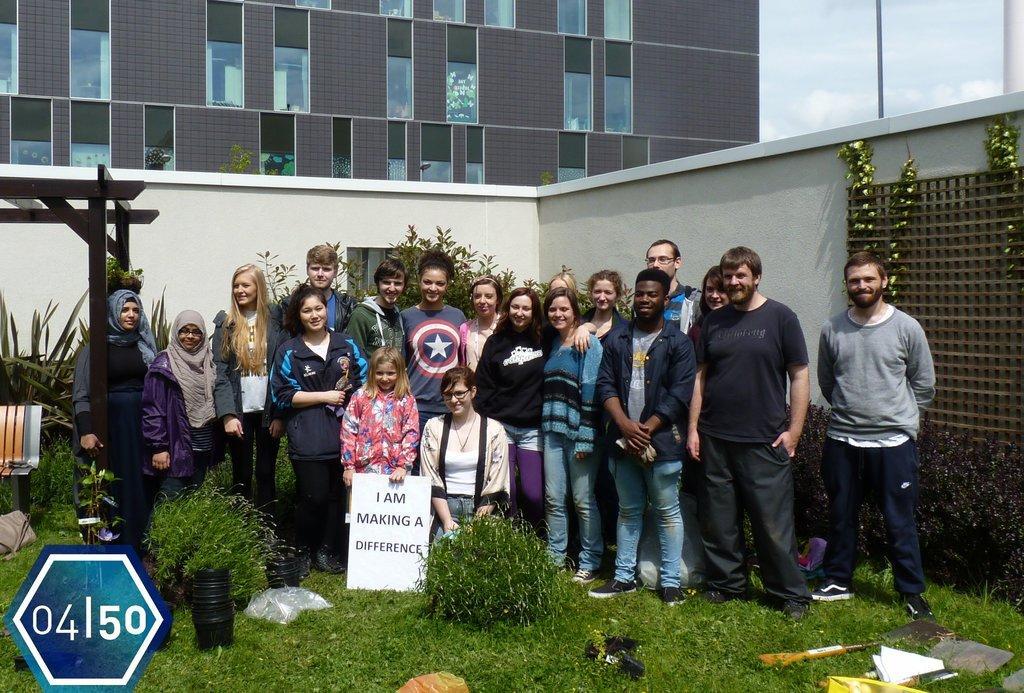Describe this image in one or two sentences. In this image there are people standing on the grassland having plants. A girl is holding a board which is having some text. Right bottom few objects are on the grassland. Left side there is a bench under the roof. There are creeper plants on the wall. Behind there is a building. Right top there is sky, having clouds. 